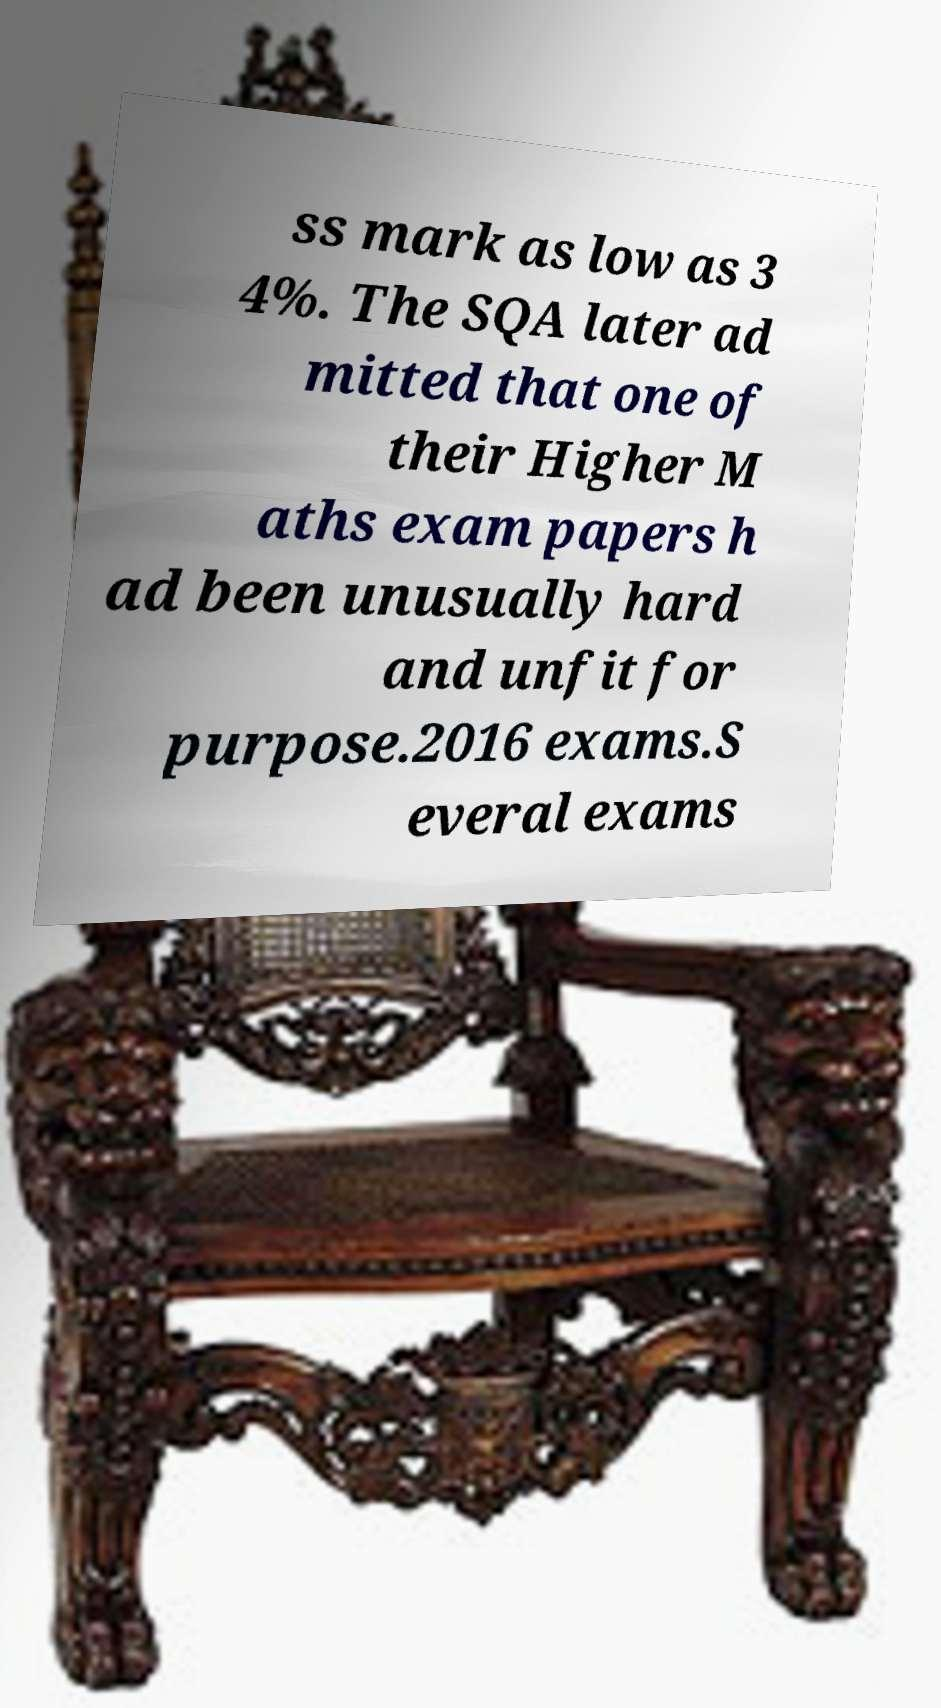Could you extract and type out the text from this image? ss mark as low as 3 4%. The SQA later ad mitted that one of their Higher M aths exam papers h ad been unusually hard and unfit for purpose.2016 exams.S everal exams 